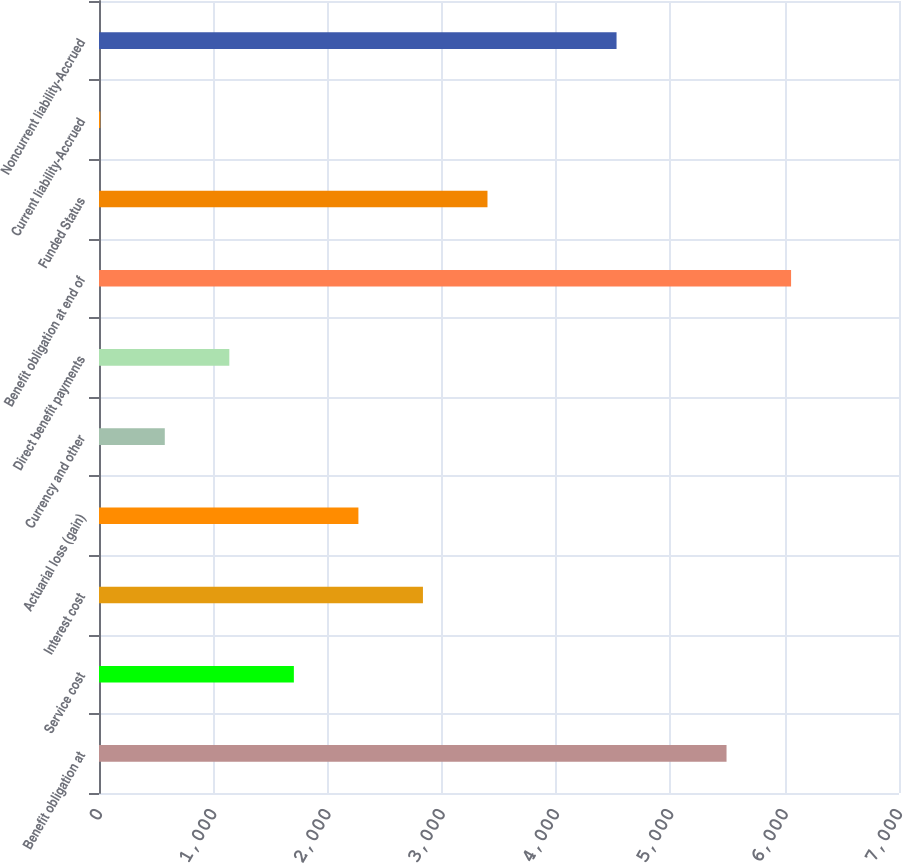<chart> <loc_0><loc_0><loc_500><loc_500><bar_chart><fcel>Benefit obligation at<fcel>Service cost<fcel>Interest cost<fcel>Actuarial loss (gain)<fcel>Currency and other<fcel>Direct benefit payments<fcel>Benefit obligation at end of<fcel>Funded Status<fcel>Current liability-Accrued<fcel>Noncurrent liability-Accrued<nl><fcel>5491<fcel>1705.1<fcel>2834.5<fcel>2269.8<fcel>575.7<fcel>1140.4<fcel>6055.7<fcel>3399.2<fcel>11<fcel>4528.6<nl></chart> 